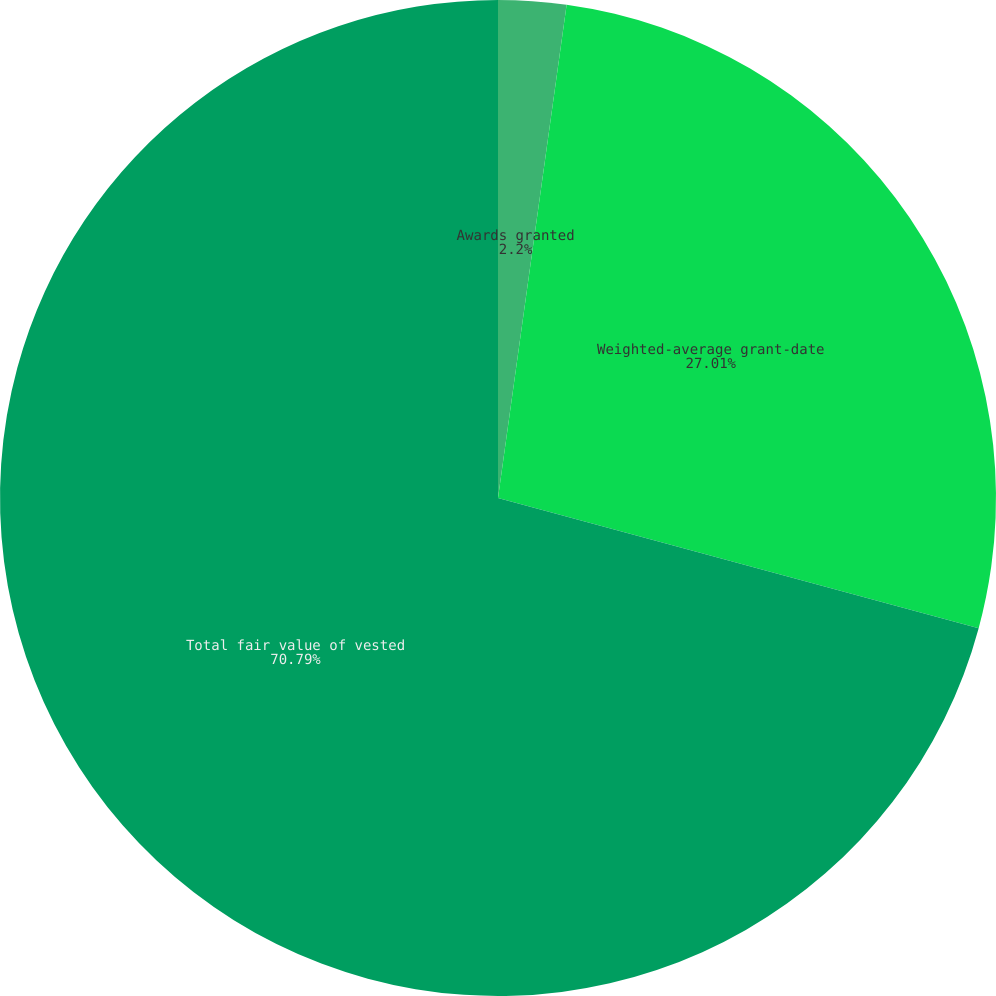Convert chart. <chart><loc_0><loc_0><loc_500><loc_500><pie_chart><fcel>Awards granted<fcel>Weighted-average grant-date<fcel>Total fair value of vested<nl><fcel>2.2%<fcel>27.01%<fcel>70.79%<nl></chart> 